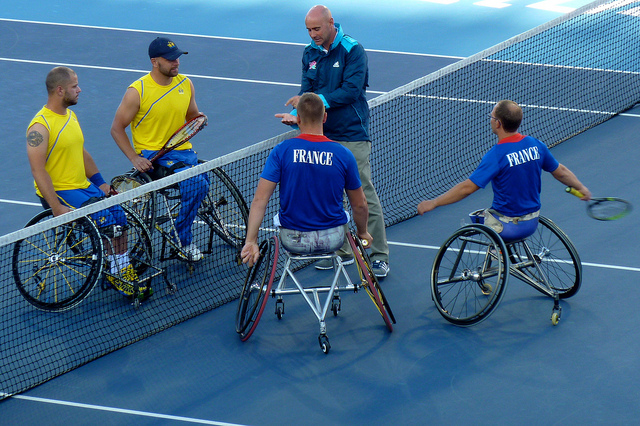Identify the text displayed in this image. FRANCE FRANCE 